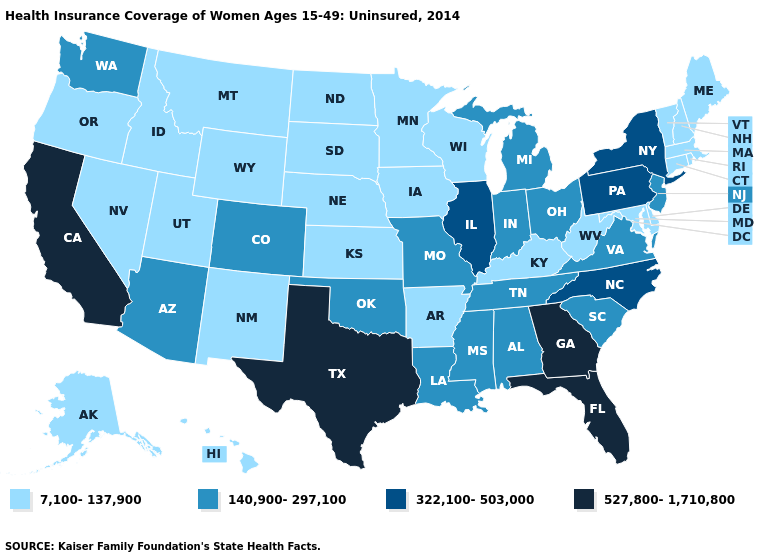Does Texas have the highest value in the USA?
Concise answer only. Yes. What is the value of Virginia?
Be succinct. 140,900-297,100. Does the map have missing data?
Answer briefly. No. Among the states that border Florida , does Georgia have the lowest value?
Keep it brief. No. What is the value of Ohio?
Quick response, please. 140,900-297,100. What is the lowest value in the USA?
Be succinct. 7,100-137,900. Name the states that have a value in the range 527,800-1,710,800?
Answer briefly. California, Florida, Georgia, Texas. Name the states that have a value in the range 140,900-297,100?
Concise answer only. Alabama, Arizona, Colorado, Indiana, Louisiana, Michigan, Mississippi, Missouri, New Jersey, Ohio, Oklahoma, South Carolina, Tennessee, Virginia, Washington. What is the highest value in states that border California?
Concise answer only. 140,900-297,100. What is the lowest value in the USA?
Keep it brief. 7,100-137,900. What is the lowest value in the MidWest?
Write a very short answer. 7,100-137,900. Which states have the lowest value in the South?
Be succinct. Arkansas, Delaware, Kentucky, Maryland, West Virginia. Name the states that have a value in the range 140,900-297,100?
Keep it brief. Alabama, Arizona, Colorado, Indiana, Louisiana, Michigan, Mississippi, Missouri, New Jersey, Ohio, Oklahoma, South Carolina, Tennessee, Virginia, Washington. Name the states that have a value in the range 527,800-1,710,800?
Short answer required. California, Florida, Georgia, Texas. Name the states that have a value in the range 140,900-297,100?
Write a very short answer. Alabama, Arizona, Colorado, Indiana, Louisiana, Michigan, Mississippi, Missouri, New Jersey, Ohio, Oklahoma, South Carolina, Tennessee, Virginia, Washington. 